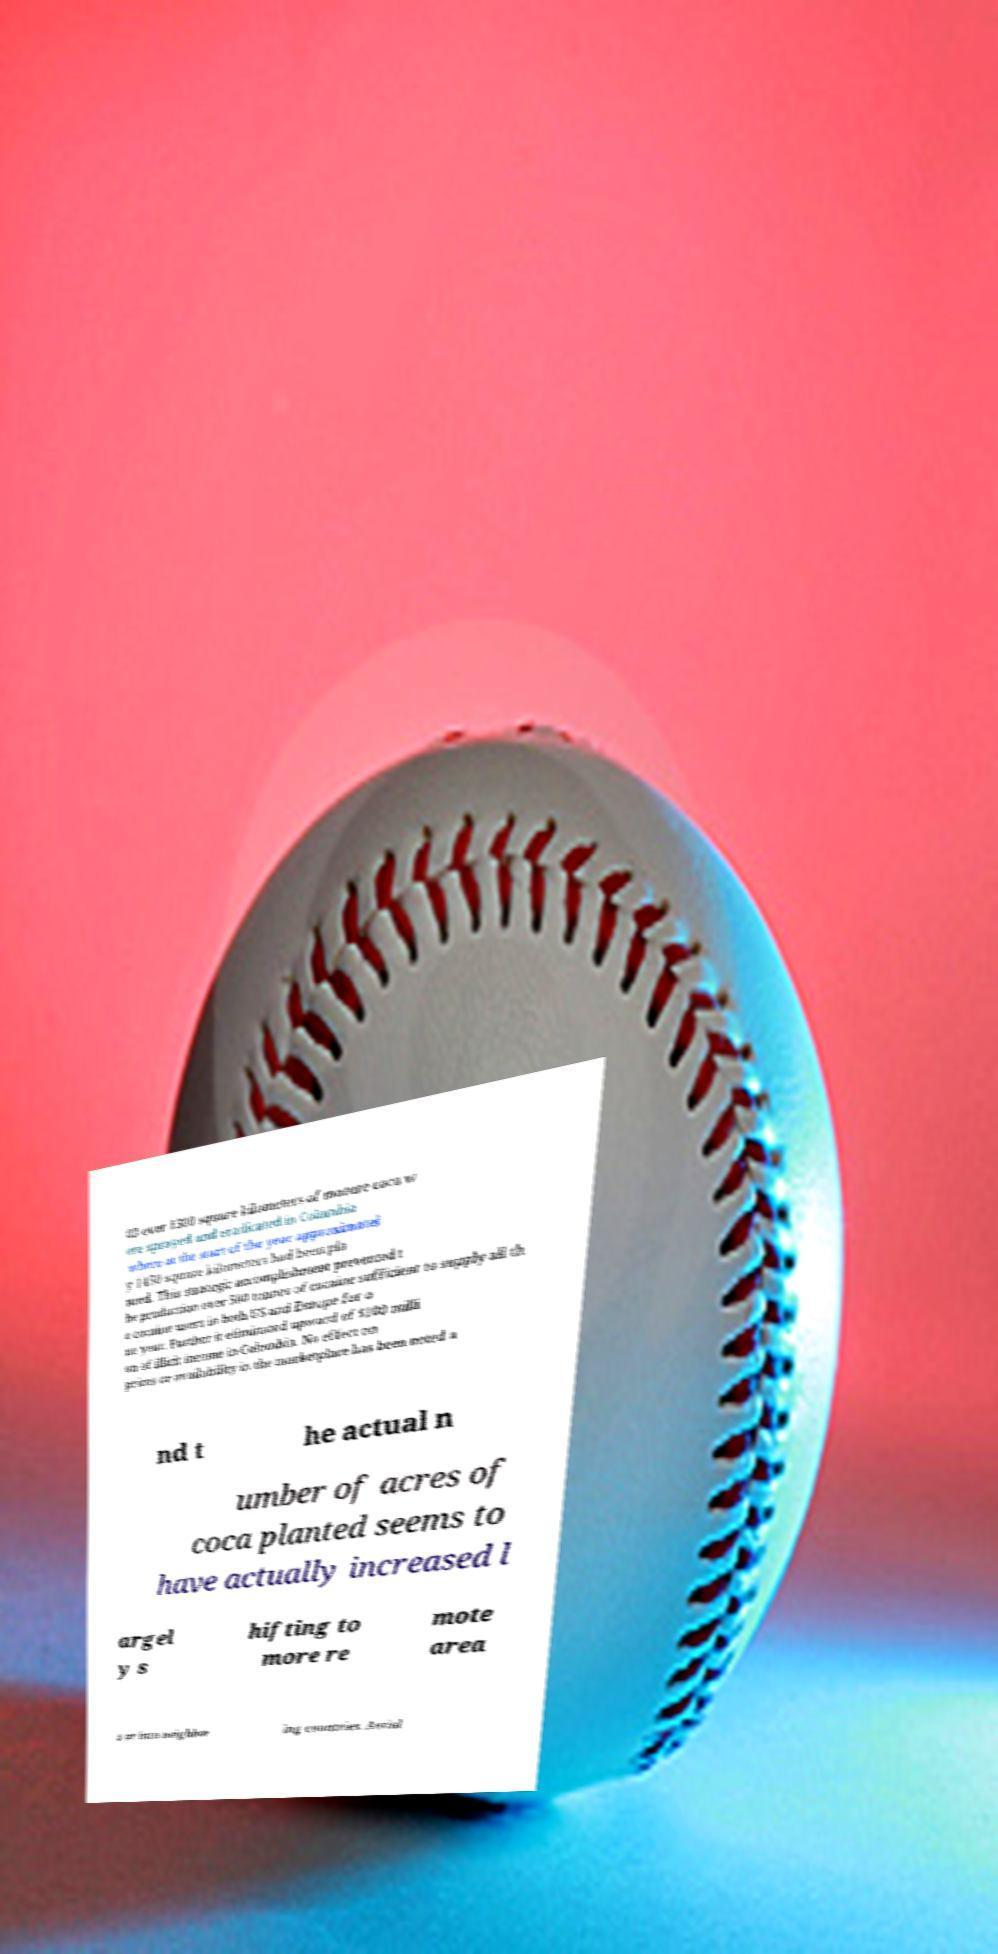Please read and relay the text visible in this image. What does it say? 03 over 1300 square kilometers of mature coca w ere sprayed and eradicated in Colombia where at the start of the year approximatel y 1450 square kilometers had been pla nted. This strategic accomplishment prevented t he production over 500 tonnes of cocaine sufficient to supply all th e cocaine users in both US and Europe for o ne year. Further it eliminated upward of $100 milli on of illicit income in Colombia. No effect on prices or availability in the marketplace has been noted a nd t he actual n umber of acres of coca planted seems to have actually increased l argel y s hifting to more re mote area s or into neighbor ing countries. Aerial 